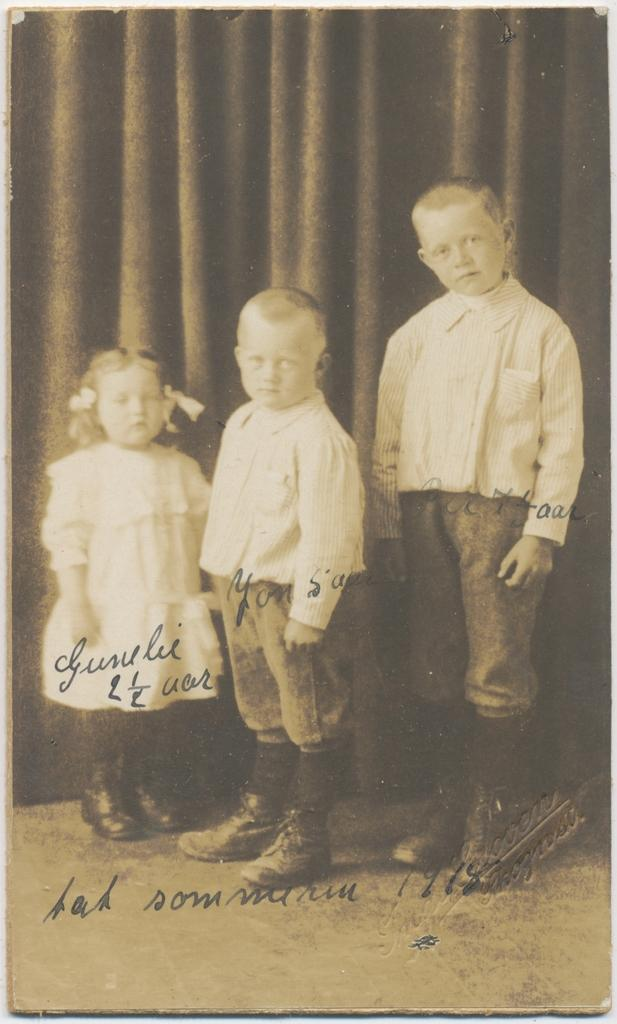What type of image is visible in the picture? There is an old photograph in the image. How many children are in the photograph? The photograph contains two boys and a girl. What are the children in the photograph doing? The children in the photograph are standing. What are the children wearing in the photograph? The children in the photograph are wearing clothes and shoes. What can be seen in the background of the photograph? There is a floor visible in the image, and there are curtains present. Is there any text present in the image? Yes, there is text present in the image. What type of process is being controlled by the children in the image? There is no process or control being depicted in the image; it is a photograph of children standing and wearing clothes. 